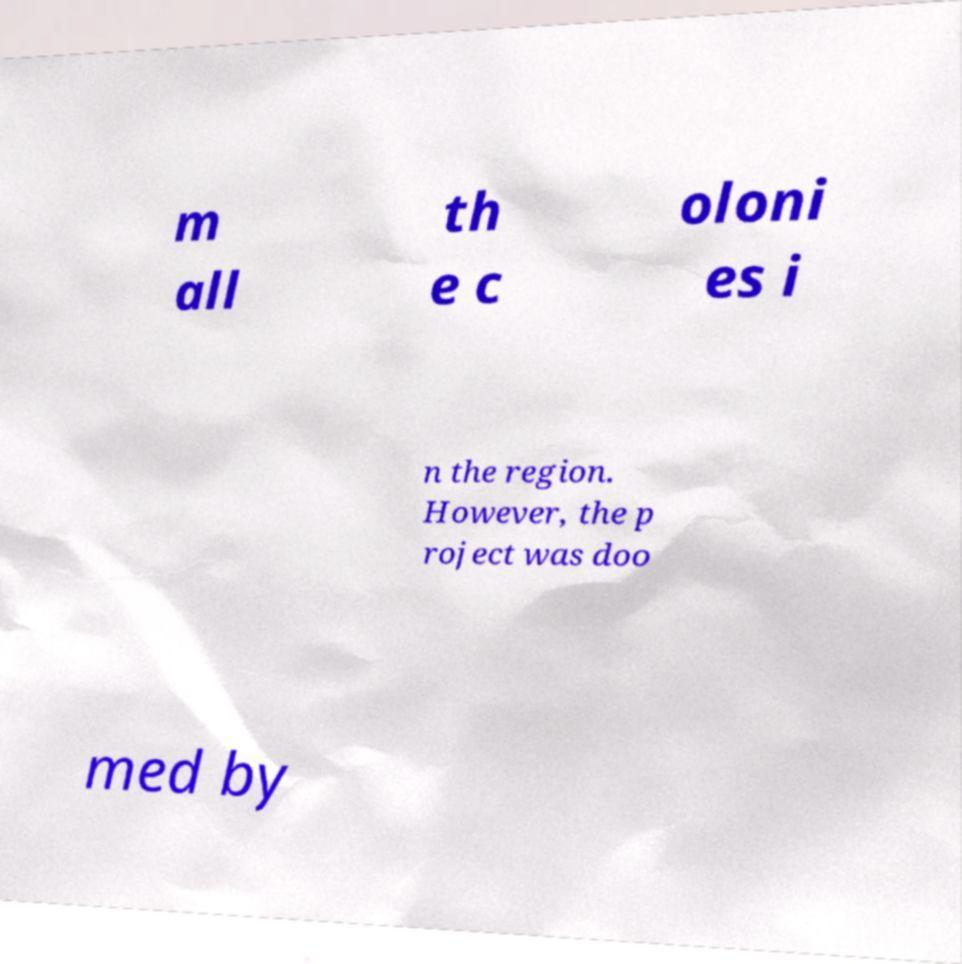For documentation purposes, I need the text within this image transcribed. Could you provide that? m all th e c oloni es i n the region. However, the p roject was doo med by 